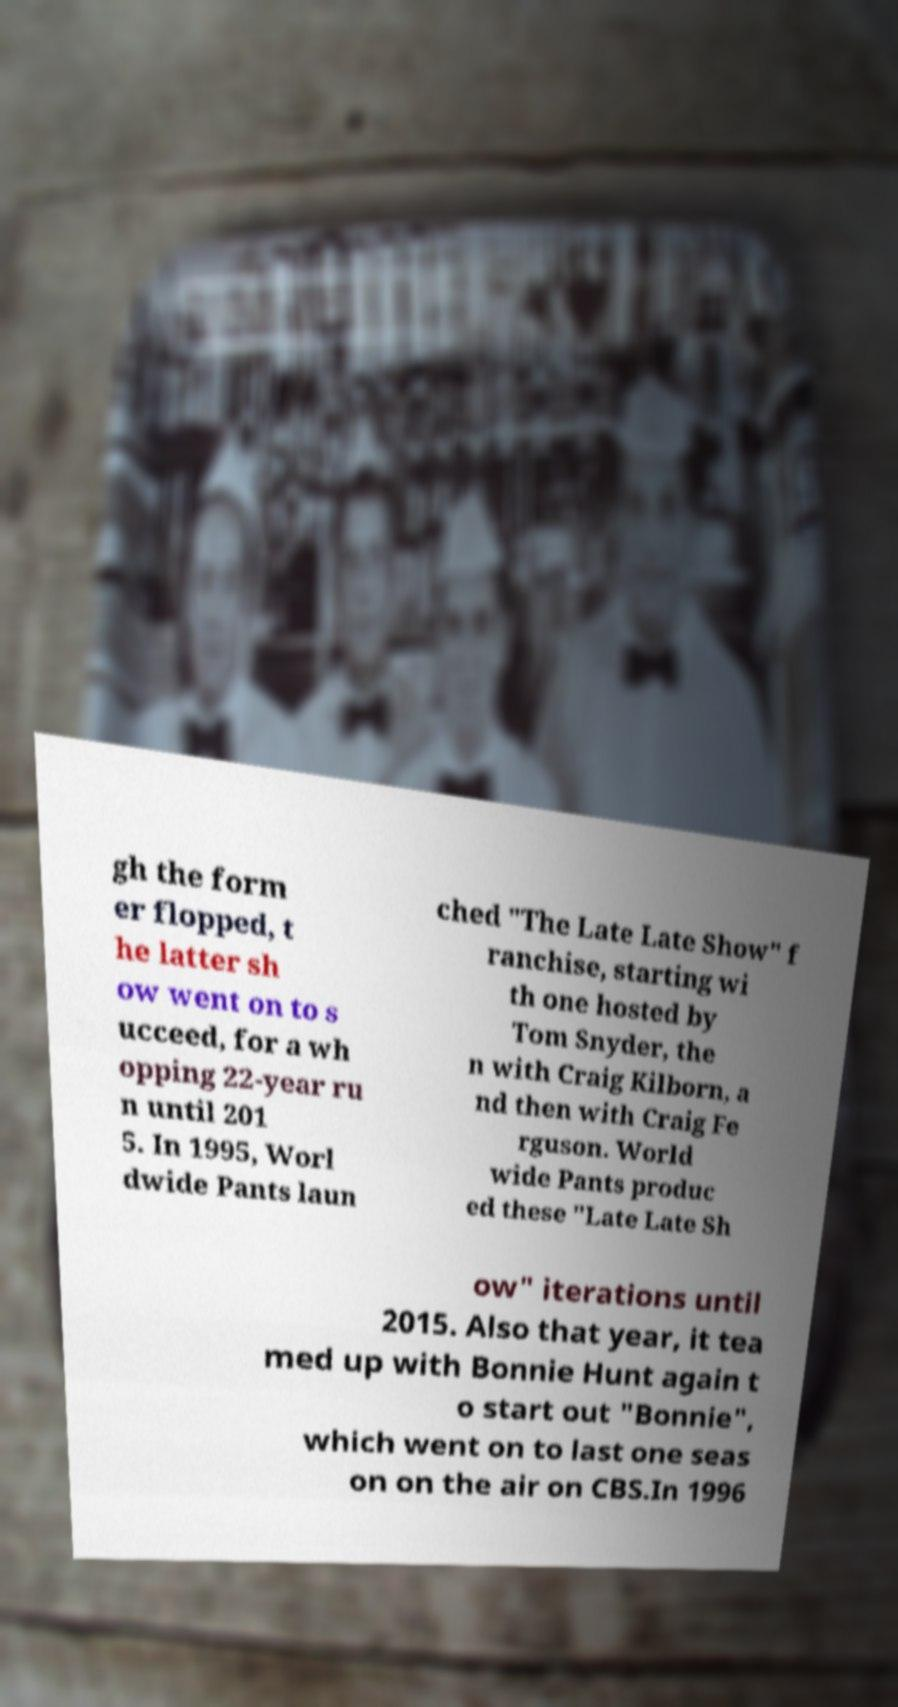Could you assist in decoding the text presented in this image and type it out clearly? gh the form er flopped, t he latter sh ow went on to s ucceed, for a wh opping 22-year ru n until 201 5. In 1995, Worl dwide Pants laun ched "The Late Late Show" f ranchise, starting wi th one hosted by Tom Snyder, the n with Craig Kilborn, a nd then with Craig Fe rguson. World wide Pants produc ed these "Late Late Sh ow" iterations until 2015. Also that year, it tea med up with Bonnie Hunt again t o start out "Bonnie", which went on to last one seas on on the air on CBS.In 1996 